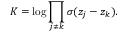<formula> <loc_0><loc_0><loc_500><loc_500>K = \log \prod _ { j \neq k } \sigma ( z _ { j } - z _ { k } ) .</formula> 